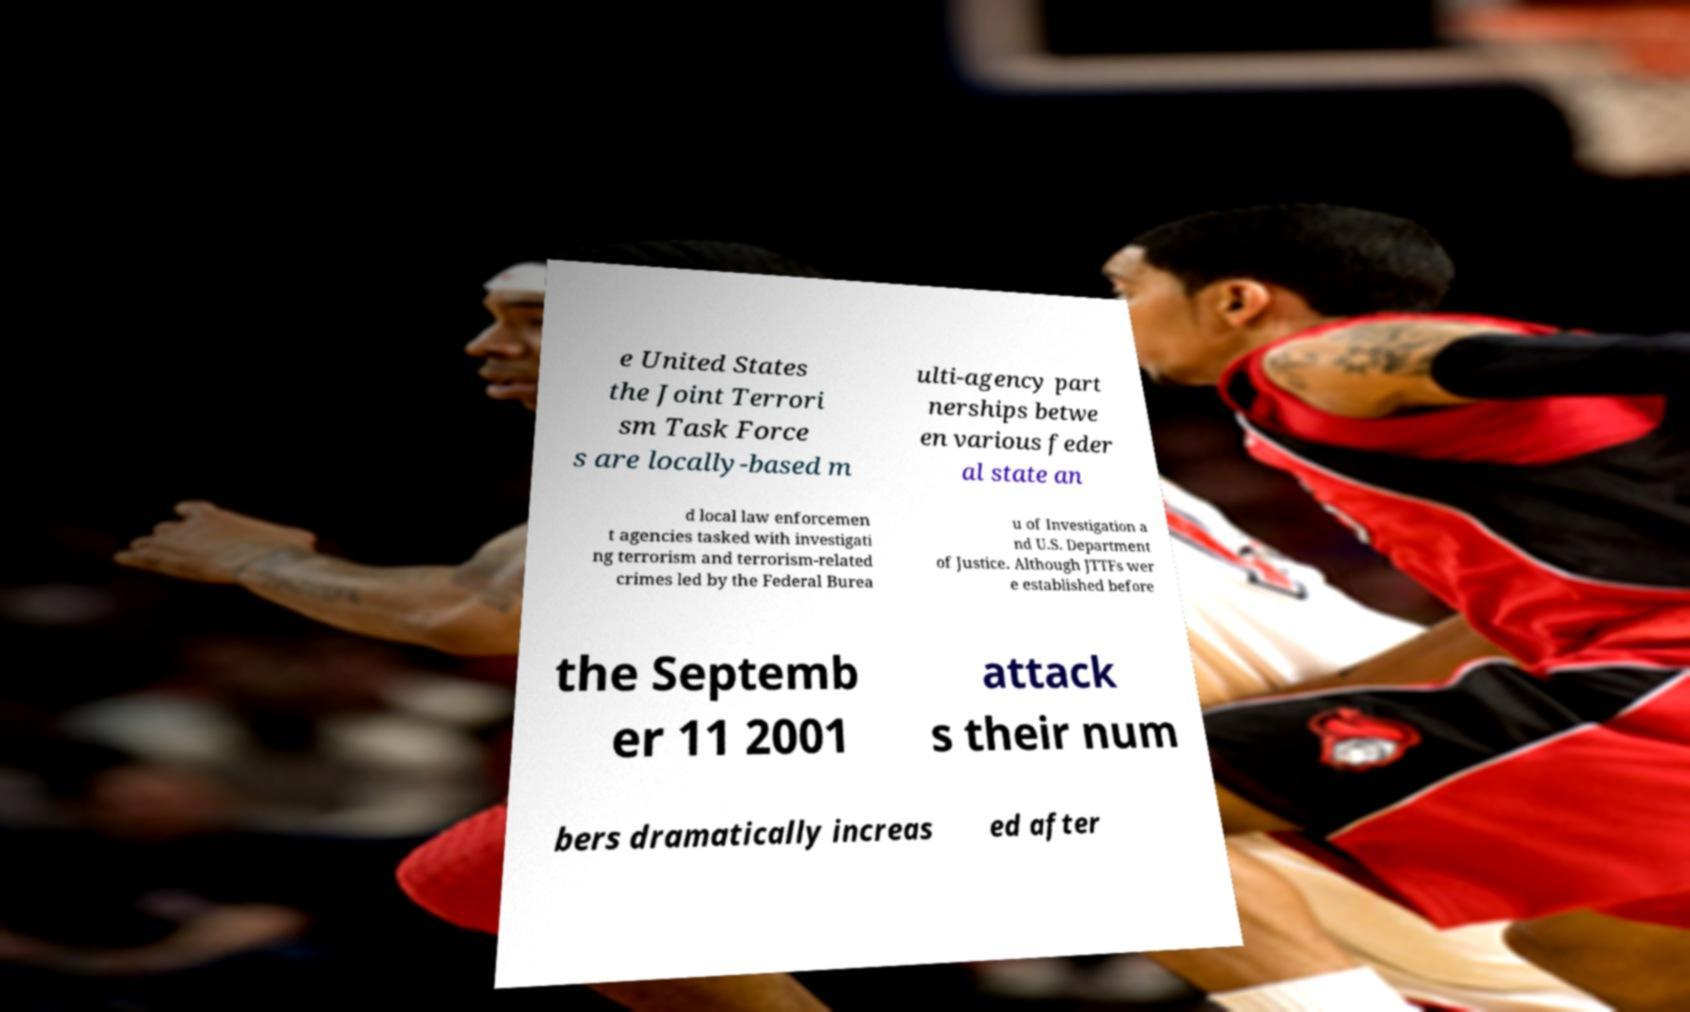What messages or text are displayed in this image? I need them in a readable, typed format. e United States the Joint Terrori sm Task Force s are locally-based m ulti-agency part nerships betwe en various feder al state an d local law enforcemen t agencies tasked with investigati ng terrorism and terrorism-related crimes led by the Federal Burea u of Investigation a nd U.S. Department of Justice. Although JTTFs wer e established before the Septemb er 11 2001 attack s their num bers dramatically increas ed after 